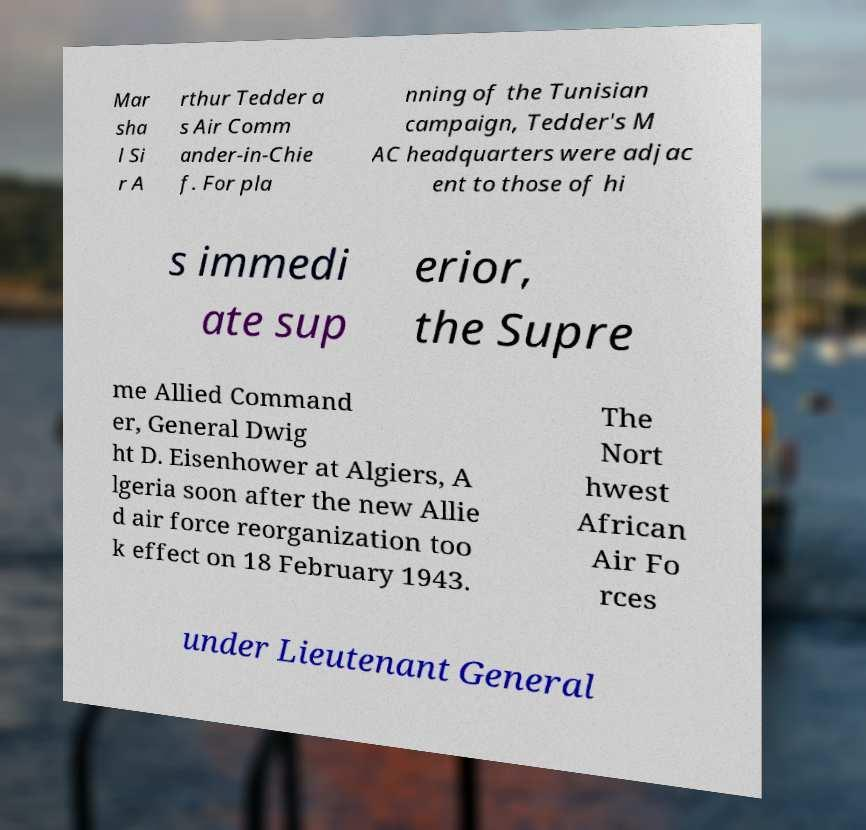There's text embedded in this image that I need extracted. Can you transcribe it verbatim? Mar sha l Si r A rthur Tedder a s Air Comm ander-in-Chie f. For pla nning of the Tunisian campaign, Tedder's M AC headquarters were adjac ent to those of hi s immedi ate sup erior, the Supre me Allied Command er, General Dwig ht D. Eisenhower at Algiers, A lgeria soon after the new Allie d air force reorganization too k effect on 18 February 1943. The Nort hwest African Air Fo rces under Lieutenant General 